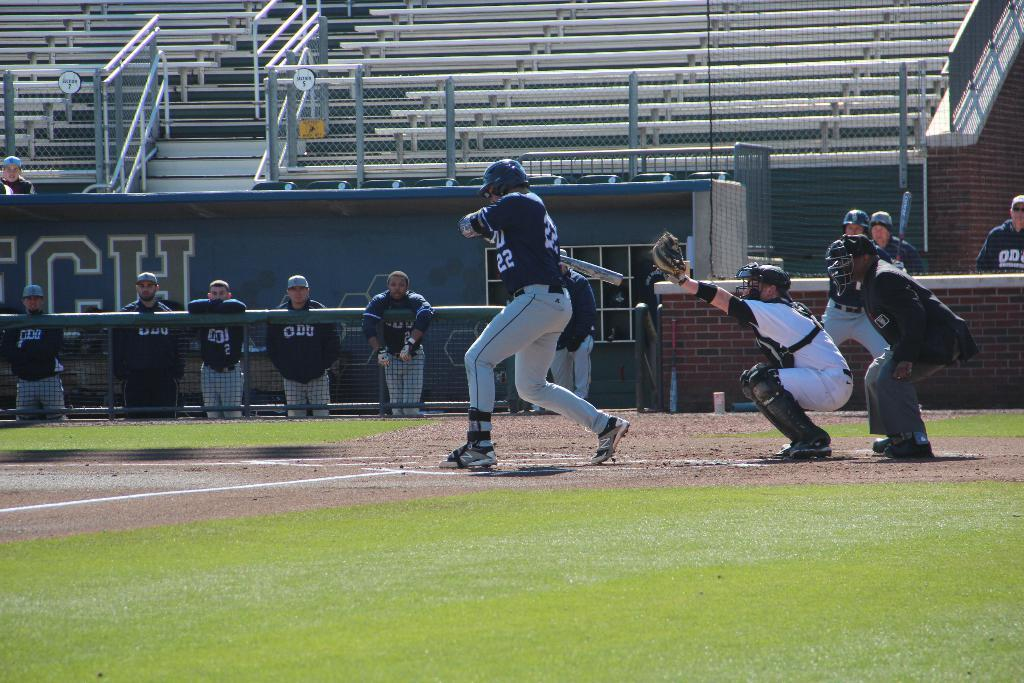Provide a one-sentence caption for the provided image. a baseball field with  number 22 at bat. 